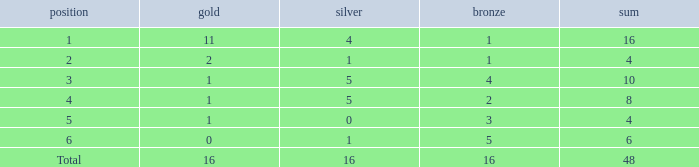How many gold are a rank 1 and larger than 16? 0.0. 